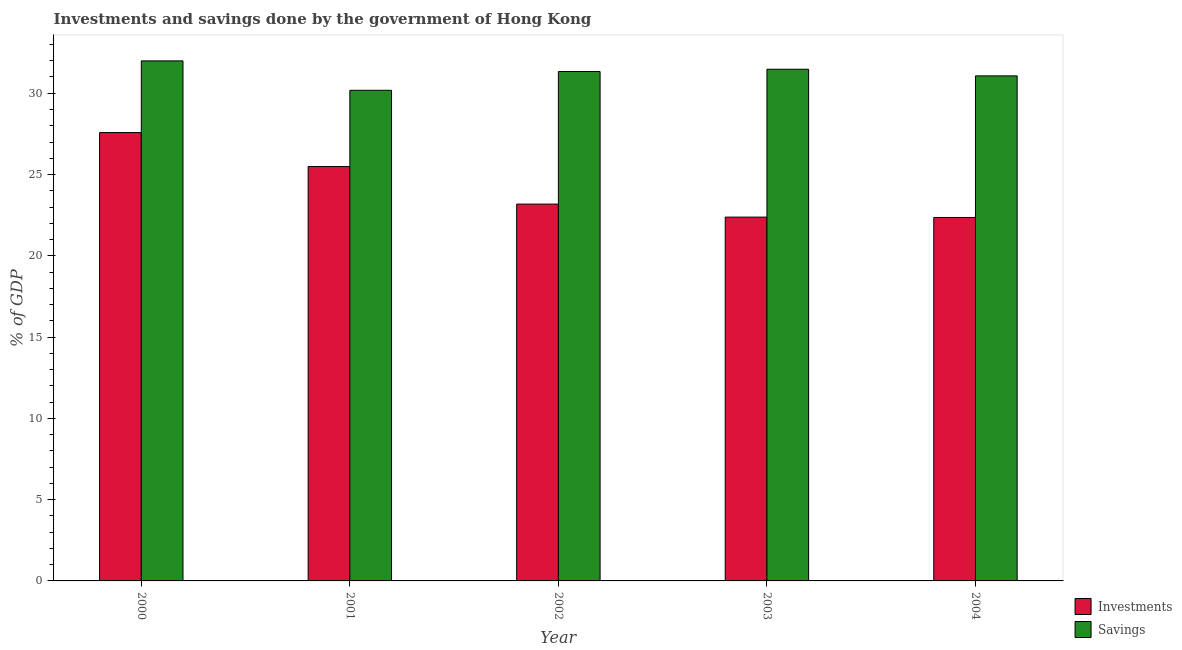How many different coloured bars are there?
Your answer should be compact. 2. How many groups of bars are there?
Your answer should be compact. 5. Are the number of bars per tick equal to the number of legend labels?
Your answer should be very brief. Yes. How many bars are there on the 4th tick from the left?
Provide a short and direct response. 2. How many bars are there on the 2nd tick from the right?
Your answer should be compact. 2. In how many cases, is the number of bars for a given year not equal to the number of legend labels?
Offer a very short reply. 0. What is the investments of government in 2000?
Your answer should be compact. 27.58. Across all years, what is the maximum investments of government?
Keep it short and to the point. 27.58. Across all years, what is the minimum investments of government?
Provide a short and direct response. 22.36. What is the total savings of government in the graph?
Make the answer very short. 156.06. What is the difference between the savings of government in 2000 and that in 2001?
Give a very brief answer. 1.81. What is the difference between the savings of government in 2001 and the investments of government in 2004?
Your answer should be very brief. -0.89. What is the average investments of government per year?
Your response must be concise. 24.2. In how many years, is the savings of government greater than 10 %?
Provide a succinct answer. 5. What is the ratio of the investments of government in 2002 to that in 2003?
Keep it short and to the point. 1.04. What is the difference between the highest and the second highest investments of government?
Make the answer very short. 2.09. What is the difference between the highest and the lowest savings of government?
Keep it short and to the point. 1.81. What does the 1st bar from the left in 2000 represents?
Provide a succinct answer. Investments. What does the 1st bar from the right in 2003 represents?
Provide a succinct answer. Savings. How many years are there in the graph?
Your answer should be very brief. 5. What is the title of the graph?
Provide a succinct answer. Investments and savings done by the government of Hong Kong. Does "Public funds" appear as one of the legend labels in the graph?
Give a very brief answer. No. What is the label or title of the X-axis?
Your answer should be very brief. Year. What is the label or title of the Y-axis?
Your answer should be very brief. % of GDP. What is the % of GDP of Investments in 2000?
Give a very brief answer. 27.58. What is the % of GDP of Savings in 2000?
Keep it short and to the point. 31.99. What is the % of GDP in Investments in 2001?
Offer a very short reply. 25.49. What is the % of GDP in Savings in 2001?
Provide a short and direct response. 30.18. What is the % of GDP in Investments in 2002?
Provide a succinct answer. 23.18. What is the % of GDP of Savings in 2002?
Make the answer very short. 31.34. What is the % of GDP in Investments in 2003?
Make the answer very short. 22.38. What is the % of GDP of Savings in 2003?
Provide a short and direct response. 31.48. What is the % of GDP of Investments in 2004?
Your answer should be very brief. 22.36. What is the % of GDP of Savings in 2004?
Offer a terse response. 31.07. Across all years, what is the maximum % of GDP in Investments?
Offer a terse response. 27.58. Across all years, what is the maximum % of GDP of Savings?
Give a very brief answer. 31.99. Across all years, what is the minimum % of GDP in Investments?
Give a very brief answer. 22.36. Across all years, what is the minimum % of GDP of Savings?
Provide a succinct answer. 30.18. What is the total % of GDP of Investments in the graph?
Your answer should be compact. 120.99. What is the total % of GDP in Savings in the graph?
Provide a short and direct response. 156.06. What is the difference between the % of GDP of Investments in 2000 and that in 2001?
Ensure brevity in your answer.  2.09. What is the difference between the % of GDP in Savings in 2000 and that in 2001?
Offer a very short reply. 1.81. What is the difference between the % of GDP in Investments in 2000 and that in 2002?
Keep it short and to the point. 4.4. What is the difference between the % of GDP in Savings in 2000 and that in 2002?
Keep it short and to the point. 0.65. What is the difference between the % of GDP in Investments in 2000 and that in 2003?
Your response must be concise. 5.2. What is the difference between the % of GDP in Savings in 2000 and that in 2003?
Offer a very short reply. 0.51. What is the difference between the % of GDP of Investments in 2000 and that in 2004?
Offer a very short reply. 5.22. What is the difference between the % of GDP in Savings in 2000 and that in 2004?
Your answer should be very brief. 0.92. What is the difference between the % of GDP of Investments in 2001 and that in 2002?
Your response must be concise. 2.31. What is the difference between the % of GDP of Savings in 2001 and that in 2002?
Make the answer very short. -1.16. What is the difference between the % of GDP in Investments in 2001 and that in 2003?
Offer a very short reply. 3.11. What is the difference between the % of GDP of Savings in 2001 and that in 2003?
Your answer should be very brief. -1.3. What is the difference between the % of GDP of Investments in 2001 and that in 2004?
Make the answer very short. 3.13. What is the difference between the % of GDP of Savings in 2001 and that in 2004?
Your answer should be compact. -0.89. What is the difference between the % of GDP in Investments in 2002 and that in 2003?
Offer a terse response. 0.8. What is the difference between the % of GDP in Savings in 2002 and that in 2003?
Offer a very short reply. -0.14. What is the difference between the % of GDP of Investments in 2002 and that in 2004?
Keep it short and to the point. 0.82. What is the difference between the % of GDP in Savings in 2002 and that in 2004?
Offer a terse response. 0.27. What is the difference between the % of GDP in Investments in 2003 and that in 2004?
Your answer should be compact. 0.02. What is the difference between the % of GDP in Savings in 2003 and that in 2004?
Give a very brief answer. 0.41. What is the difference between the % of GDP in Investments in 2000 and the % of GDP in Savings in 2001?
Ensure brevity in your answer.  -2.6. What is the difference between the % of GDP in Investments in 2000 and the % of GDP in Savings in 2002?
Offer a very short reply. -3.76. What is the difference between the % of GDP in Investments in 2000 and the % of GDP in Savings in 2003?
Provide a short and direct response. -3.89. What is the difference between the % of GDP of Investments in 2000 and the % of GDP of Savings in 2004?
Provide a short and direct response. -3.49. What is the difference between the % of GDP of Investments in 2001 and the % of GDP of Savings in 2002?
Give a very brief answer. -5.85. What is the difference between the % of GDP of Investments in 2001 and the % of GDP of Savings in 2003?
Provide a succinct answer. -5.99. What is the difference between the % of GDP of Investments in 2001 and the % of GDP of Savings in 2004?
Ensure brevity in your answer.  -5.58. What is the difference between the % of GDP in Investments in 2002 and the % of GDP in Savings in 2003?
Ensure brevity in your answer.  -8.3. What is the difference between the % of GDP of Investments in 2002 and the % of GDP of Savings in 2004?
Your response must be concise. -7.89. What is the difference between the % of GDP in Investments in 2003 and the % of GDP in Savings in 2004?
Offer a terse response. -8.69. What is the average % of GDP of Investments per year?
Provide a short and direct response. 24.2. What is the average % of GDP in Savings per year?
Provide a short and direct response. 31.21. In the year 2000, what is the difference between the % of GDP in Investments and % of GDP in Savings?
Make the answer very short. -4.41. In the year 2001, what is the difference between the % of GDP of Investments and % of GDP of Savings?
Make the answer very short. -4.69. In the year 2002, what is the difference between the % of GDP of Investments and % of GDP of Savings?
Make the answer very short. -8.16. In the year 2003, what is the difference between the % of GDP of Investments and % of GDP of Savings?
Offer a very short reply. -9.1. In the year 2004, what is the difference between the % of GDP in Investments and % of GDP in Savings?
Make the answer very short. -8.71. What is the ratio of the % of GDP in Investments in 2000 to that in 2001?
Offer a terse response. 1.08. What is the ratio of the % of GDP of Savings in 2000 to that in 2001?
Keep it short and to the point. 1.06. What is the ratio of the % of GDP of Investments in 2000 to that in 2002?
Provide a short and direct response. 1.19. What is the ratio of the % of GDP of Savings in 2000 to that in 2002?
Your response must be concise. 1.02. What is the ratio of the % of GDP of Investments in 2000 to that in 2003?
Your response must be concise. 1.23. What is the ratio of the % of GDP in Savings in 2000 to that in 2003?
Keep it short and to the point. 1.02. What is the ratio of the % of GDP of Investments in 2000 to that in 2004?
Make the answer very short. 1.23. What is the ratio of the % of GDP of Savings in 2000 to that in 2004?
Give a very brief answer. 1.03. What is the ratio of the % of GDP in Investments in 2001 to that in 2002?
Make the answer very short. 1.1. What is the ratio of the % of GDP in Savings in 2001 to that in 2002?
Offer a very short reply. 0.96. What is the ratio of the % of GDP of Investments in 2001 to that in 2003?
Your response must be concise. 1.14. What is the ratio of the % of GDP of Savings in 2001 to that in 2003?
Provide a succinct answer. 0.96. What is the ratio of the % of GDP of Investments in 2001 to that in 2004?
Your answer should be compact. 1.14. What is the ratio of the % of GDP in Savings in 2001 to that in 2004?
Offer a terse response. 0.97. What is the ratio of the % of GDP of Investments in 2002 to that in 2003?
Ensure brevity in your answer.  1.04. What is the ratio of the % of GDP in Savings in 2002 to that in 2003?
Offer a very short reply. 1. What is the ratio of the % of GDP in Investments in 2002 to that in 2004?
Your answer should be very brief. 1.04. What is the ratio of the % of GDP in Savings in 2002 to that in 2004?
Your response must be concise. 1.01. What is the ratio of the % of GDP in Investments in 2003 to that in 2004?
Your answer should be very brief. 1. What is the ratio of the % of GDP of Savings in 2003 to that in 2004?
Make the answer very short. 1.01. What is the difference between the highest and the second highest % of GDP in Investments?
Provide a succinct answer. 2.09. What is the difference between the highest and the second highest % of GDP in Savings?
Give a very brief answer. 0.51. What is the difference between the highest and the lowest % of GDP of Investments?
Ensure brevity in your answer.  5.22. What is the difference between the highest and the lowest % of GDP in Savings?
Your answer should be compact. 1.81. 